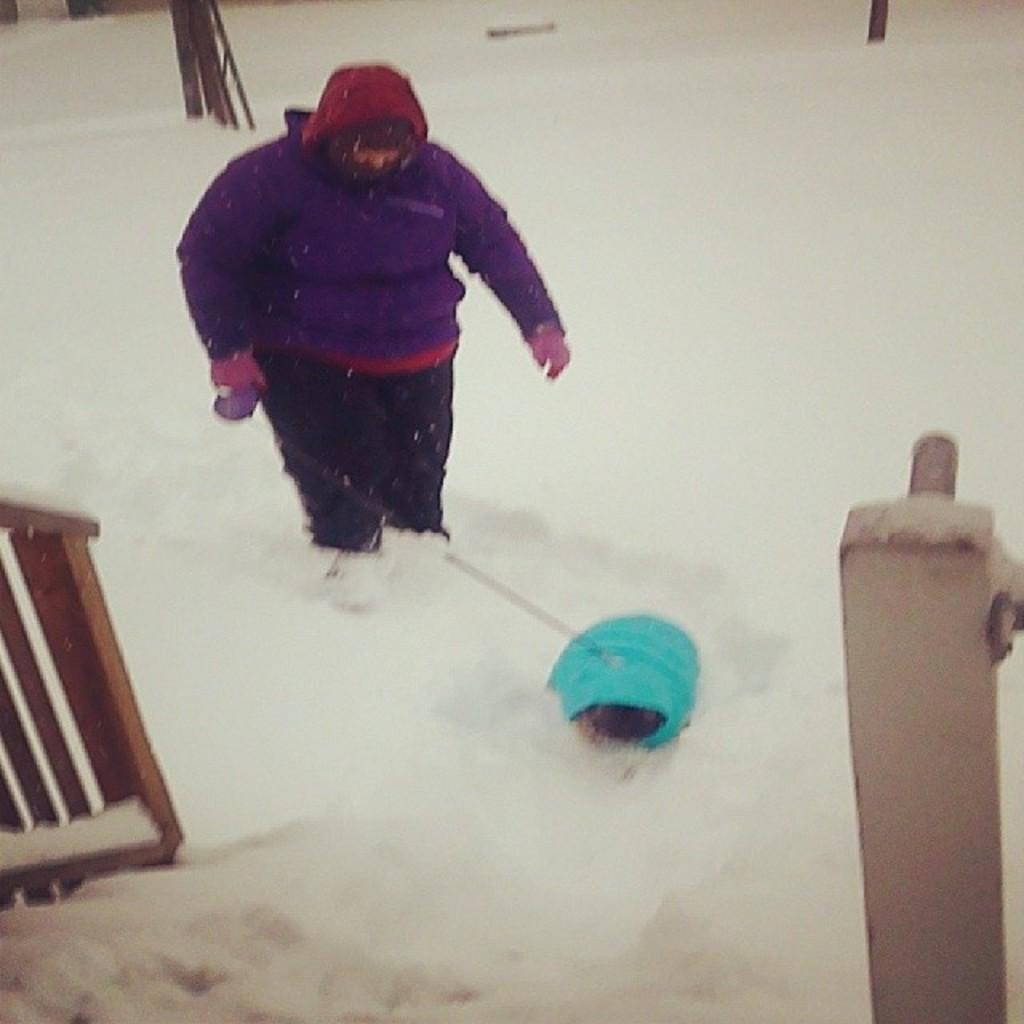What type of animal is present in the image? There appears to be a dog in the image. What is the human doing with the dog? The human is holding the dog with a string. What is the ground covered with in the image? There is snow on the ground in the image. What type of calendar is hanging on the coast in the image? There is no calendar or coast present in the image; it features a human holding a dog with a string on a snowy ground. 